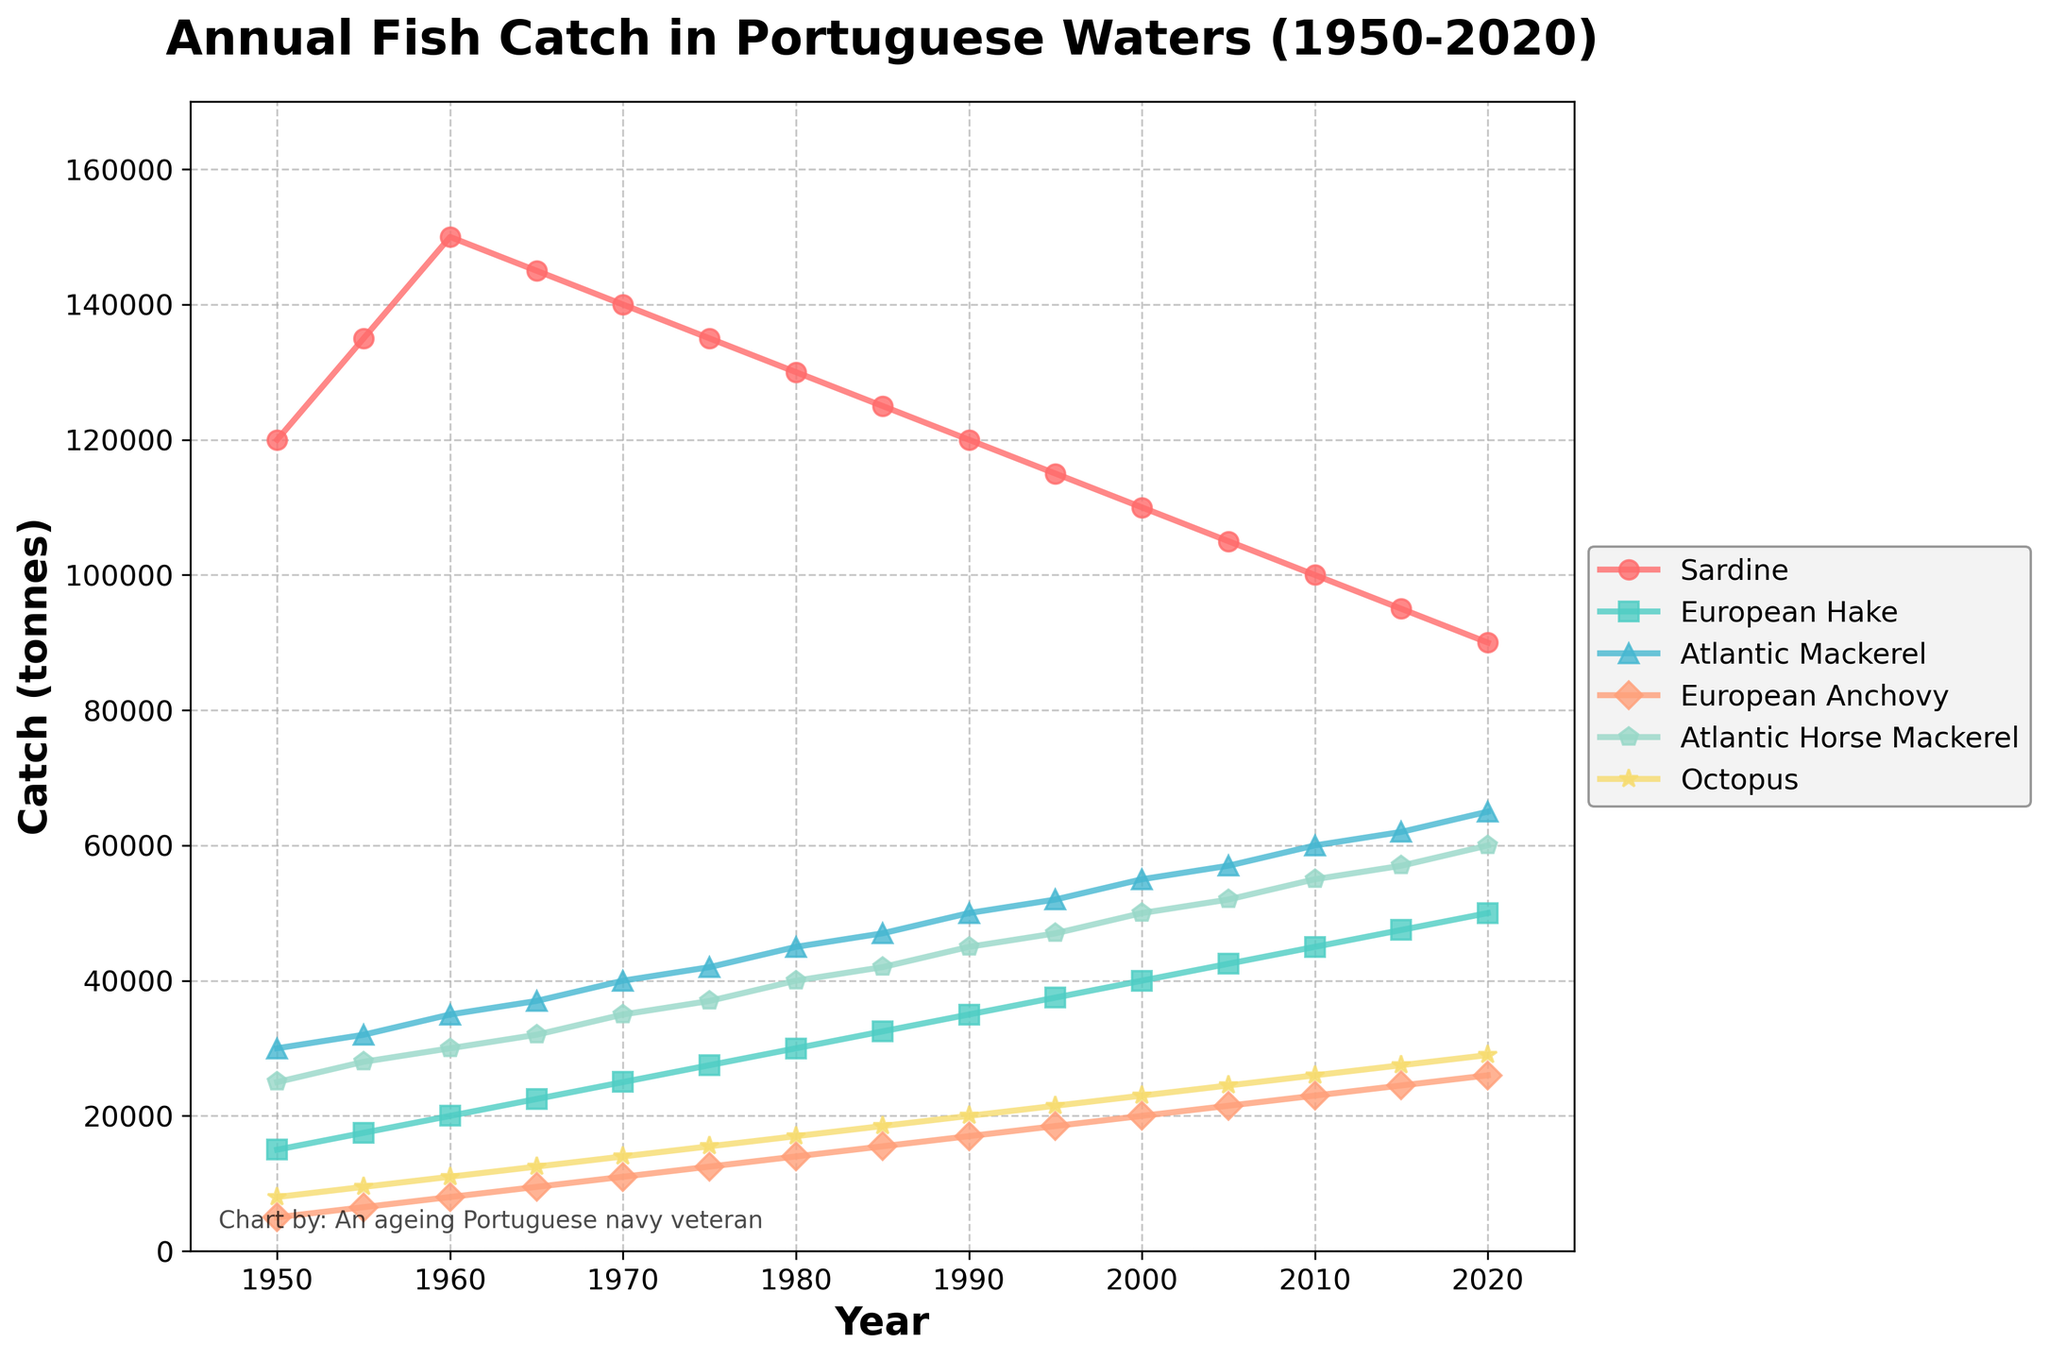What is the general trend for the sardine catch from 1950 to 2020? Observe the line representing sardines in the figure. The sardine catch generally shows a decreasing trend over the period from 1950 to 2020. It started high around 120,000 tonnes and dropped to about 90,000 tonnes by 2020.
Answer: Decreasing Which species had the highest catch in 2020, and what was the approximate amount? Look at the figure for the year 2020 and compare the heights of all the lines at that point. The sardine had the highest catch in 2020 at approximately 90,000 tonnes.
Answer: Sardine, 90,000 tonnes Compare the catch of Atlantic Mackerel between 1950 and 2000. By how much did it increase? Find the points for Atlantic Mackerel in 1950 and 2000 on the figure. In 1950, the catch was 30,000 tonnes, and in 2000, it was 55,000 tonnes. Therefore, the increase is 55,000 - 30,000 = 25,000 tonnes.
Answer: 25,000 tonnes Which species had the most consistent catch over the period from 1950 to 2020? Examine each line's variation over the period. The Octopus' line seems the most consistent without significant spikes or drops, indicating the most consistent catch.
Answer: Octopus In which decade did European Hake experience the highest increase in catch? For European Hake, compare the increments in each decade on the figure. The largest increase can be observed from 1950 (15,000 tonnes) to 1960 (20,000 tonnes), an increase of 5,000 tonnes.
Answer: 1950s Find the average catch of European Anchovy from 2000 to 2020. Sum up the catches for European Anchovy for the years 2000, 2005, 2010, 2015, and 2020, then divide by the number of years: (20,000 + 21,500 + 23,000 + 24,500 + 26,000) / 5 = 23,000 tonnes.
Answer: 23,000 tonnes How does the catch of Atlantic Horse Mackerel in 1975 compare to its catch in 1995? Compare the heights of the lines for Atlantic Horse Mackerel at 1975 and 1995 on the figure. The catch was 37,000 tonnes in 1975 and 47,000 tonnes in 1995, which means it increased by 10,000 tonnes.
Answer: Increased by 10,000 tonnes Which species shows a visible increasing trend in its catch from 1950 to 2020? Identify the line that shows an upwards trend throughout the period. The European Hake displays a clear increasing trend from 15,000 tonnes in 1950 to 50,000 tonnes in 2020.
Answer: European Hake What is the difference in catch amounts between Sardine and European Anchovy in 2020? Look at the catch amounts for Sardine and European Anchovy in 2020. Sardine caught 90,000 tonnes and European Anchovy caught 26,000 tonnes. Therefore, the difference is 90,000 - 26,000 = 64,000 tonnes.
Answer: 64,000 tonnes 